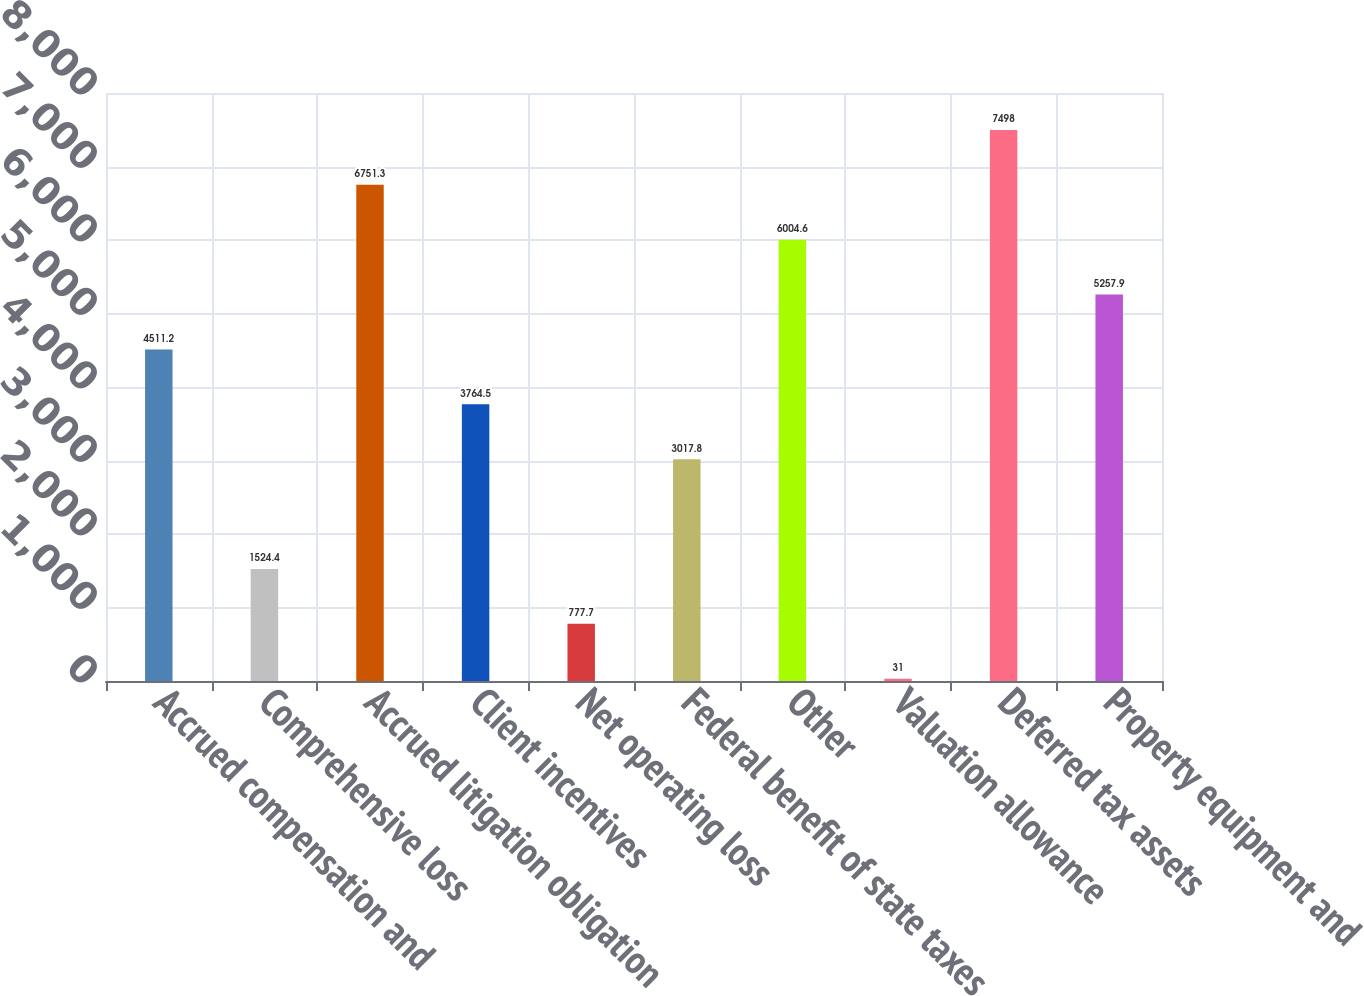Convert chart to OTSL. <chart><loc_0><loc_0><loc_500><loc_500><bar_chart><fcel>Accrued compensation and<fcel>Comprehensive loss<fcel>Accrued litigation obligation<fcel>Client incentives<fcel>Net operating loss<fcel>Federal benefit of state taxes<fcel>Other<fcel>Valuation allowance<fcel>Deferred tax assets<fcel>Property equipment and<nl><fcel>4511.2<fcel>1524.4<fcel>6751.3<fcel>3764.5<fcel>777.7<fcel>3017.8<fcel>6004.6<fcel>31<fcel>7498<fcel>5257.9<nl></chart> 